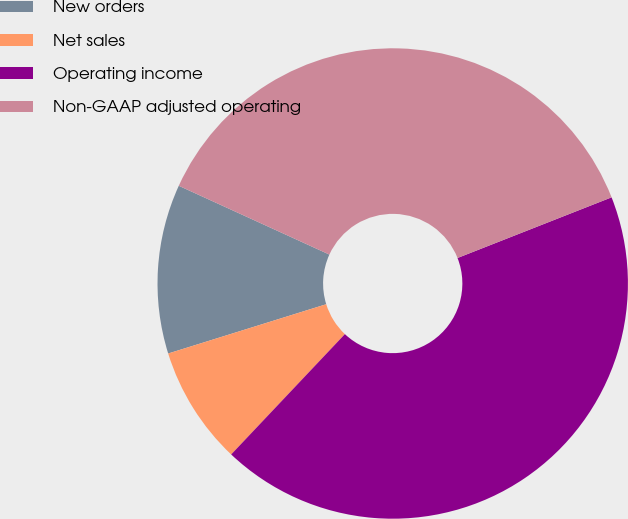Convert chart. <chart><loc_0><loc_0><loc_500><loc_500><pie_chart><fcel>New orders<fcel>Net sales<fcel>Operating income<fcel>Non-GAAP adjusted operating<nl><fcel>11.63%<fcel>8.14%<fcel>43.02%<fcel>37.21%<nl></chart> 